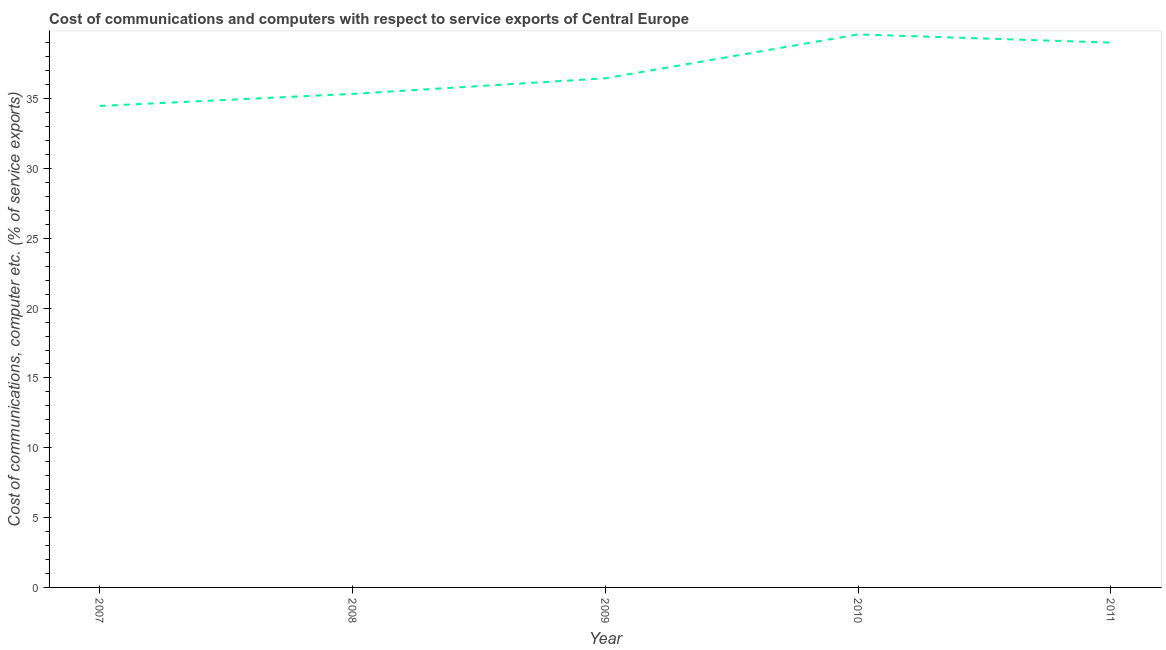What is the cost of communications and computer in 2009?
Provide a succinct answer. 36.46. Across all years, what is the maximum cost of communications and computer?
Make the answer very short. 39.6. Across all years, what is the minimum cost of communications and computer?
Your answer should be very brief. 34.48. What is the sum of the cost of communications and computer?
Your answer should be very brief. 184.89. What is the difference between the cost of communications and computer in 2008 and 2009?
Provide a succinct answer. -1.12. What is the average cost of communications and computer per year?
Keep it short and to the point. 36.98. What is the median cost of communications and computer?
Offer a terse response. 36.46. In how many years, is the cost of communications and computer greater than 21 %?
Keep it short and to the point. 5. Do a majority of the years between 2007 and 2008 (inclusive) have cost of communications and computer greater than 4 %?
Ensure brevity in your answer.  Yes. What is the ratio of the cost of communications and computer in 2007 to that in 2010?
Your response must be concise. 0.87. What is the difference between the highest and the second highest cost of communications and computer?
Ensure brevity in your answer.  0.59. What is the difference between the highest and the lowest cost of communications and computer?
Ensure brevity in your answer.  5.12. Does the cost of communications and computer monotonically increase over the years?
Offer a terse response. No. How many lines are there?
Give a very brief answer. 1. How many years are there in the graph?
Your answer should be very brief. 5. What is the difference between two consecutive major ticks on the Y-axis?
Provide a succinct answer. 5. Are the values on the major ticks of Y-axis written in scientific E-notation?
Your answer should be compact. No. Does the graph contain grids?
Offer a terse response. No. What is the title of the graph?
Your response must be concise. Cost of communications and computers with respect to service exports of Central Europe. What is the label or title of the Y-axis?
Make the answer very short. Cost of communications, computer etc. (% of service exports). What is the Cost of communications, computer etc. (% of service exports) in 2007?
Keep it short and to the point. 34.48. What is the Cost of communications, computer etc. (% of service exports) of 2008?
Offer a terse response. 35.34. What is the Cost of communications, computer etc. (% of service exports) of 2009?
Provide a short and direct response. 36.46. What is the Cost of communications, computer etc. (% of service exports) in 2010?
Make the answer very short. 39.6. What is the Cost of communications, computer etc. (% of service exports) in 2011?
Offer a very short reply. 39.01. What is the difference between the Cost of communications, computer etc. (% of service exports) in 2007 and 2008?
Offer a very short reply. -0.86. What is the difference between the Cost of communications, computer etc. (% of service exports) in 2007 and 2009?
Make the answer very short. -1.98. What is the difference between the Cost of communications, computer etc. (% of service exports) in 2007 and 2010?
Provide a succinct answer. -5.12. What is the difference between the Cost of communications, computer etc. (% of service exports) in 2007 and 2011?
Give a very brief answer. -4.53. What is the difference between the Cost of communications, computer etc. (% of service exports) in 2008 and 2009?
Provide a short and direct response. -1.12. What is the difference between the Cost of communications, computer etc. (% of service exports) in 2008 and 2010?
Provide a short and direct response. -4.26. What is the difference between the Cost of communications, computer etc. (% of service exports) in 2008 and 2011?
Offer a very short reply. -3.67. What is the difference between the Cost of communications, computer etc. (% of service exports) in 2009 and 2010?
Offer a terse response. -3.14. What is the difference between the Cost of communications, computer etc. (% of service exports) in 2009 and 2011?
Your answer should be compact. -2.55. What is the difference between the Cost of communications, computer etc. (% of service exports) in 2010 and 2011?
Provide a succinct answer. 0.59. What is the ratio of the Cost of communications, computer etc. (% of service exports) in 2007 to that in 2009?
Ensure brevity in your answer.  0.95. What is the ratio of the Cost of communications, computer etc. (% of service exports) in 2007 to that in 2010?
Your answer should be very brief. 0.87. What is the ratio of the Cost of communications, computer etc. (% of service exports) in 2007 to that in 2011?
Ensure brevity in your answer.  0.88. What is the ratio of the Cost of communications, computer etc. (% of service exports) in 2008 to that in 2010?
Offer a very short reply. 0.89. What is the ratio of the Cost of communications, computer etc. (% of service exports) in 2008 to that in 2011?
Offer a terse response. 0.91. What is the ratio of the Cost of communications, computer etc. (% of service exports) in 2009 to that in 2010?
Ensure brevity in your answer.  0.92. What is the ratio of the Cost of communications, computer etc. (% of service exports) in 2009 to that in 2011?
Your answer should be compact. 0.94. What is the ratio of the Cost of communications, computer etc. (% of service exports) in 2010 to that in 2011?
Offer a very short reply. 1.01. 